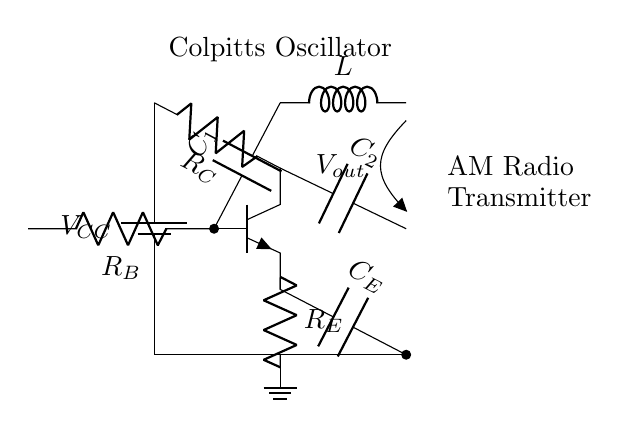What is the type of oscillator shown in the circuit? The circuit diagram includes a label stating "Colpitts Oscillator," which directly indicates the type of oscillator present.
Answer: Colpitts Oscillator How many capacitors are in the circuit? The circuit shows two capacitors labeled C1 and C2, both connected to the transistor. The presence of these two distinct components confirms the number.
Answer: Two What component is connected to the base of the transistor? The base of the transistor, represented in the diagram, has a resistor labeled RB connected to it, indicating the input component influencing the transistor's operation.
Answer: Resistor Which component influences the frequency of oscillation? The capacitors C1, C2, and the inductor L are components responsible for determining the frequency of oscillation in a Colpitts oscillator configuration by creating a resonant circuit.
Answer: Inductor and Capacitors What is the output voltage labeled as in the circuit diagram? The output voltage is explicitly labeled as "Vout" which indicates the voltage signal that can be taken from the circuit.
Answer: Vout What is the purpose of the resistor labeled R_E? The resistor R_E is connected to the emitter of the transistor, and it is used for stabilizing the biasing of the transistor while also influencing the output characteristics of the oscillator.
Answer: Stabilizing transistor bias 